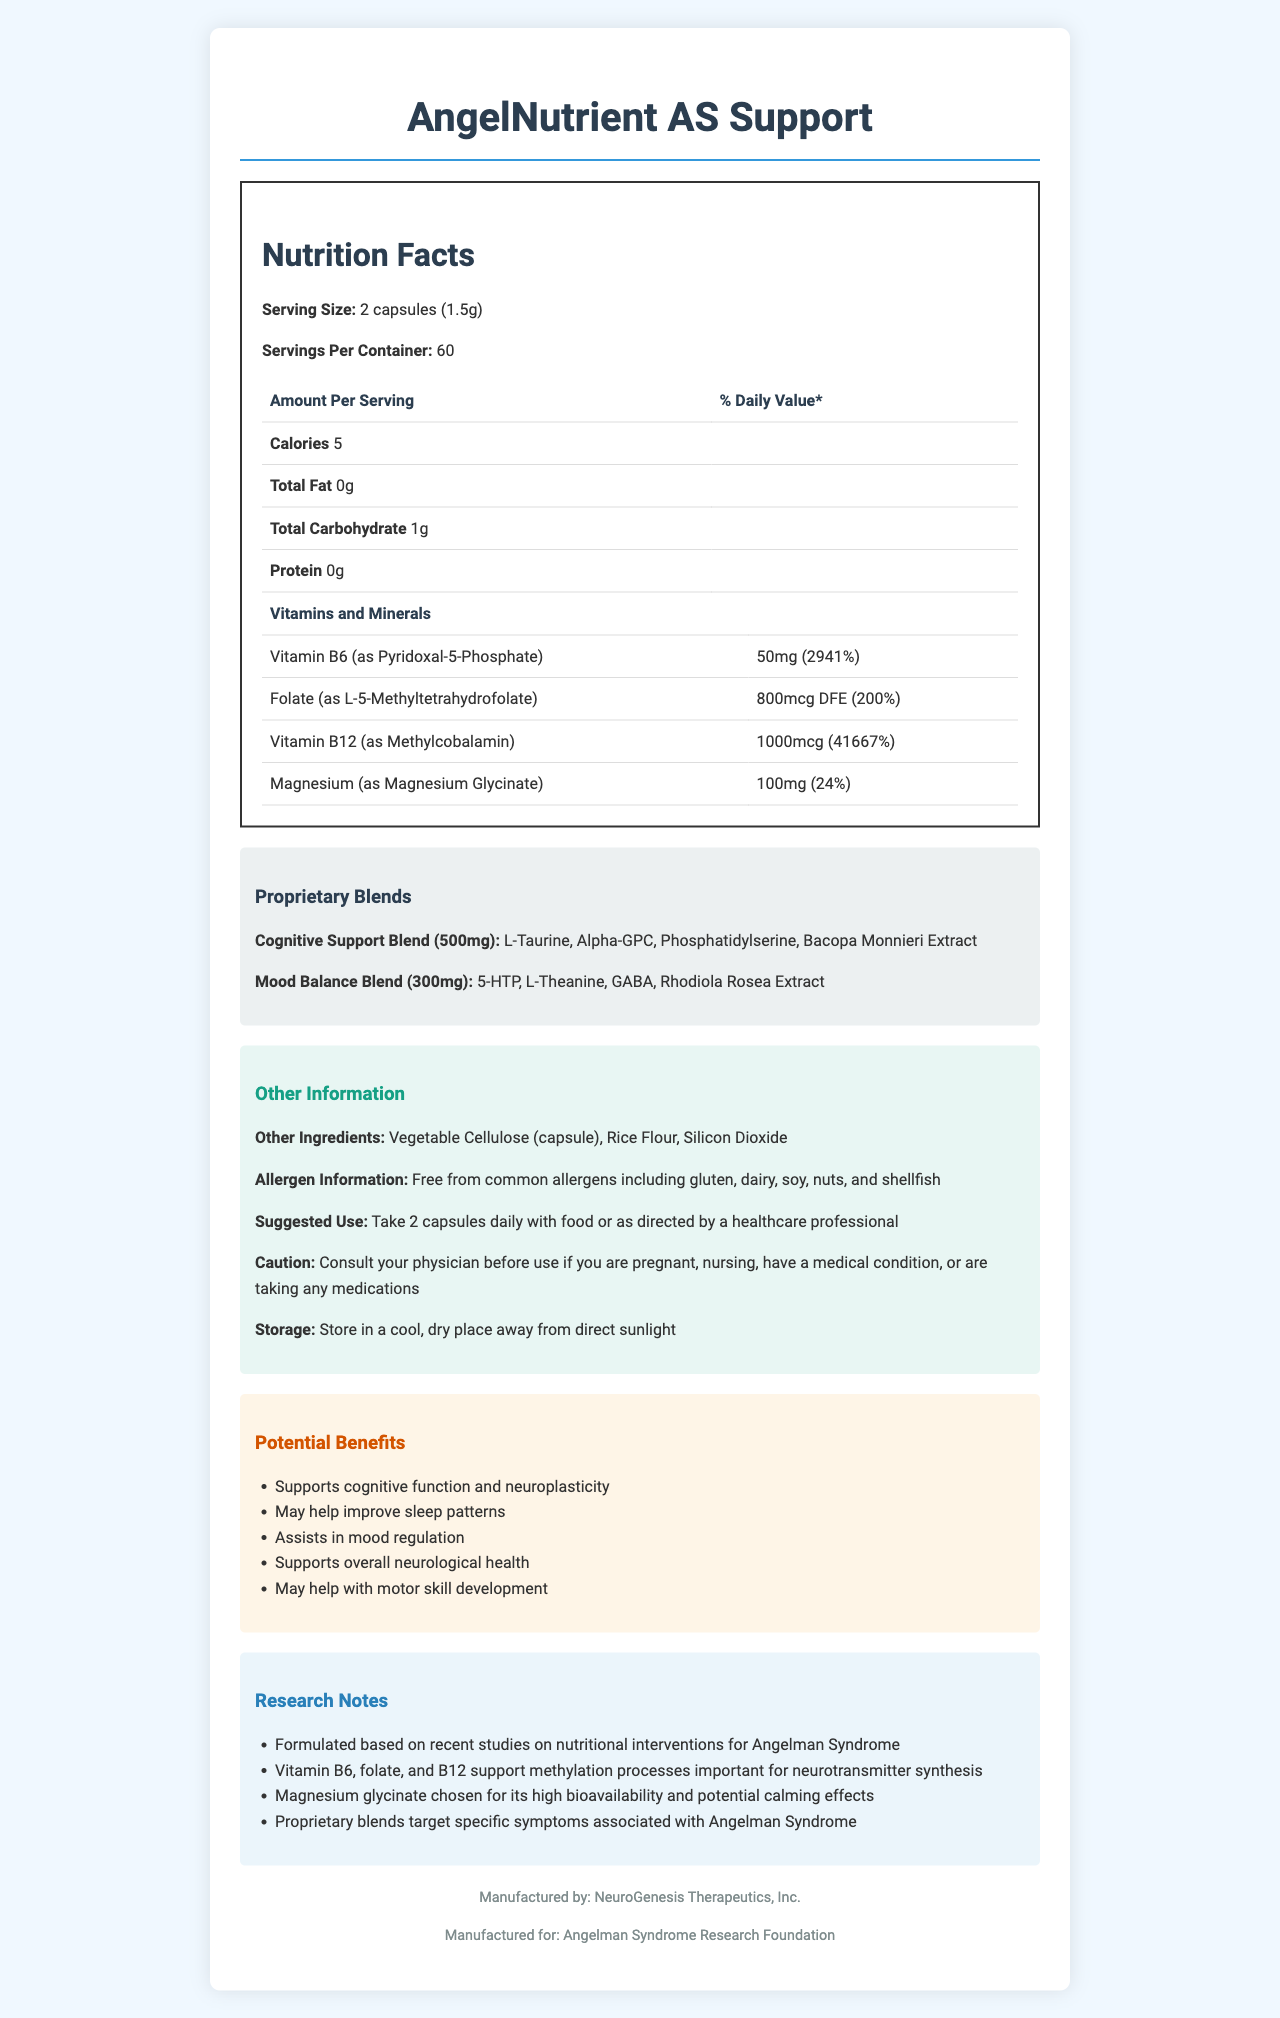what is the serving size? The serving size is stated in the "Nutrition Facts" section with the text "Serving Size: 2 capsules (1.5g)."
Answer: 2 capsules (1.5g) how many servings are in each container? The servings per container are mentioned in the "Nutrition Facts" section as "Servings Per Container: 60."
Answer: 60 how many calories are in one serving? The number of calories per serving is specified in the "Nutrition Facts" section as "Calories 5."
Answer: 5 which vitamin has the highest percentage of daily value? The highest percentage of daily value among the listed vitamins and minerals is found for Vitamin B12 with 41667%.
Answer: Vitamin B12 (41667%) what are the main ingredients in the Cognitive Support Blend? The ingredients of the Cognitive Support Blend are listed in the "Proprietary Blends" section.
Answer: L-Taurine, Alpha-GPC, Phosphatidylserine, Bacopa Monnieri Extract is this product allergen-free? The allergen information states that the product is "Free from common allergens including gluten, dairy, soy, nuts, and shellfish."
Answer: Yes which blend includes Rhodiola Rosea Extract? The Mood Balance Blend contains Rhodiola Rosea Extract, as indicated in the "Proprietary Blends" section.
Answer: Mood Balance Blend how much magnesium is in one serving? The amount of magnesium per serving is given as "Magnesium (as Magnesium Glycinate) 100mg (24%)" in the "Vitamins and Minerals" section.
Answer: 100mg which company manufactures this product? The product is manufactured by NeuroGenesis Therapeutics, Inc., noted in the footer.
Answer: NeuroGenesis Therapeutics, Inc. how does this supplement support neurological health? The research notes and potential benefits indicate that the supplement supports overall neurological health through specific vitamins, minerals, and proprietary blends.
Answer: Formulated with vitamins and minerals that support methylation processes and blends targeting cognitive function, sleep, mood, and motor skill development what are the key components of the Mood Balance Blend? The Mood Balance Blend's key components are listed in the "Proprietary Blends" section.
Answer: 5-HTP, L-Theanine, GABA, Rhodiola Rosea Extract why was magnesium glycinate chosen as an ingredient? The research notes specify that magnesium glycinate was selected for its high bioavailability and potential calming effects.
Answer: Due to its high bioavailability and potential calming effects what vitamin form is used for Vitamin B6? A. Pyridoxine Hydrochloride B. Pyridoxal-5-Phosphate C. Pyridoxamine The form of Vitamin B6 used is Pyridoxal-5-Phosphate, as indicated in the "Vitamins and Minerals" section.
Answer: B how should this supplement be stored? A. In the refrigerator B. In a cool, dry place away from direct sunlight C. At room temperature with high humidity The storage instructions specify it should be stored "in a cool, dry place away from direct sunlight."
Answer: B is this supplement intended for use by individuals who are pregnant? The caution section advises consulting a physician before use if pregnant, implying it may not be safe for pregnant individuals.
Answer: No how frequently should the supplement be taken? The suggested use specifies a daily dosage of 2 capsules with food or as directed by a healthcare professional.
Answer: Take 2 capsules daily with food or as directed by a healthcare professional does the document specify the capabilities of rice flour in the supplement? The document lists rice flour as an ingredient but does not elaborate on its specific capabilities or benefits.
Answer: No summarize the document. The summary encompasses the main details from the product name, serving information, key ingredients, proprietary blends, allergens, usage instructions, storage, potential benefits, and research notes. This concisely reflects the document's comprehensive data about the supplement.
Answer: AngelNutrient AS Support is a dietary supplement designed specifically for Angelman Syndrome patients, offering 60 servings per container with 2 capsules (1.5g) per serving. It includes essential vitamins and minerals like Vitamin B6, Folate, Vitamin B12, and Magnesium, along with proprietary blends for cognitive support and mood balance. It is free from common allergens and comes with potential benefits such as supporting cognitive function and mood regulation. The supplement should be taken daily and stored properly according to the given instructions. Conducted research underpins its formulation to assist with neurological health. 